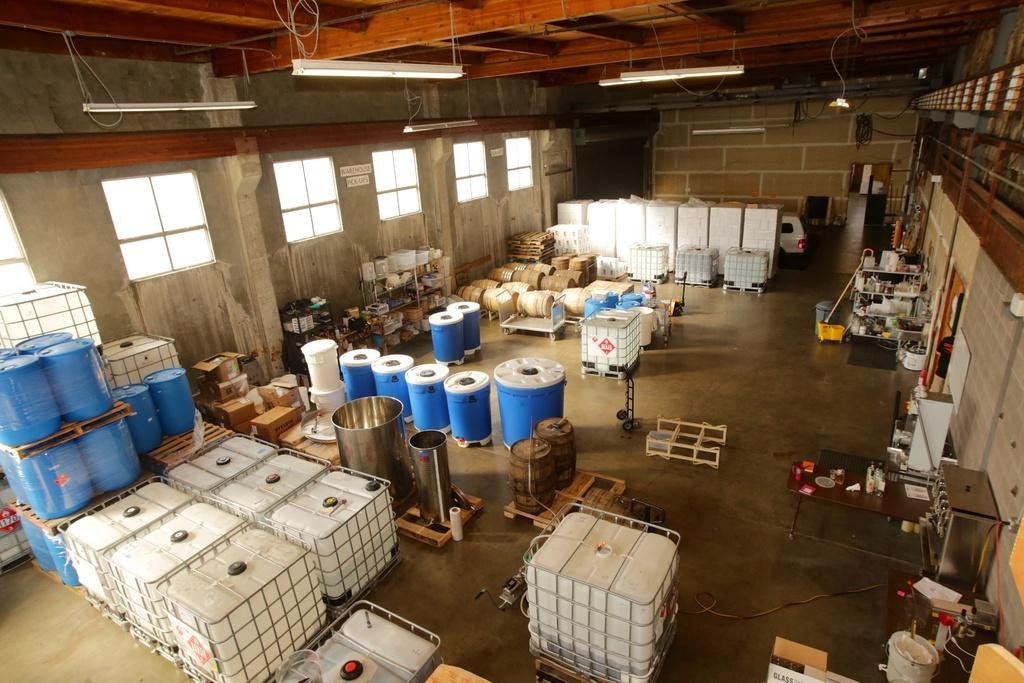What types of containers are visible in the image? There are tanks, drums, carton boxes, barrels, and buckets in the image. What objects are related to music in the image? There are drums in the image. What type of waste disposal container is present in the image? There is a dustbin in the image. What structural elements can be seen in the image? There are poles, windows, a wall, and lights hanging from the rooftop in the image. What type of vehicle is visible in the image? There is a vehicle in the image. Are there any other items present in the image besides the ones mentioned? Yes, there are other items in the image. Can you see a pickle hanging from the wall in the image? No, there is no pickle present in the image. What direction is the swing facing in the image? There is no swing present in the image. 